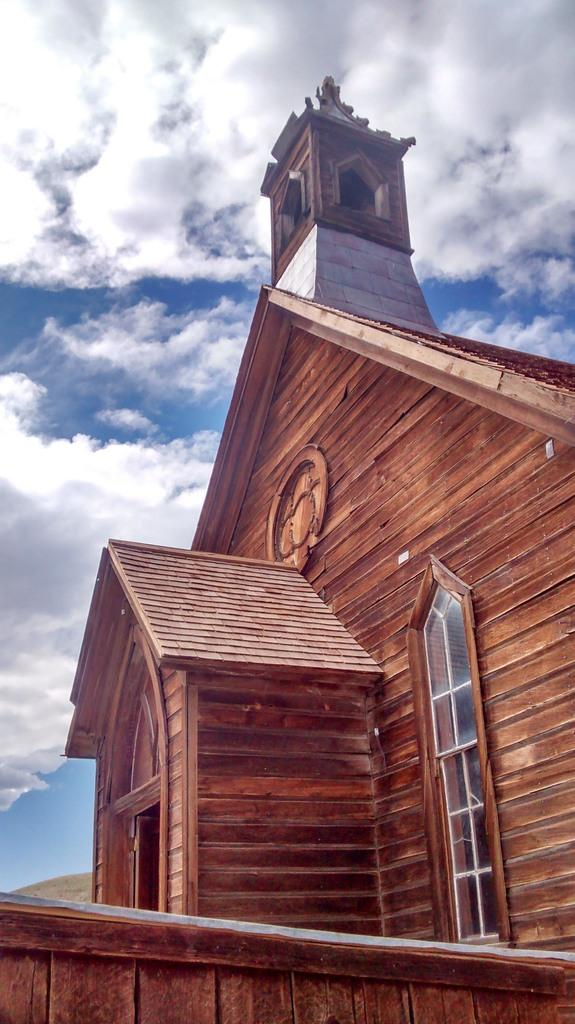What type of structure is present in the image? There is a building in the image. What part of the natural environment is visible in the image? The sky is visible in the image. What type of coil can be seen in the image? There is no coil present in the image. In which direction is the building facing in the image? The provided facts do not specify the direction the building is facing. What sense is being stimulated by the image? The image primarily stimulates the sense of sight, as it is a visual representation. 